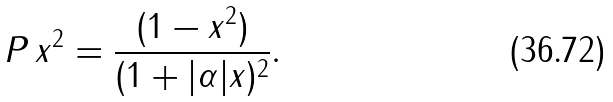Convert formula to latex. <formula><loc_0><loc_0><loc_500><loc_500>P \, x ^ { 2 } = \frac { ( 1 - x ^ { 2 } ) } { ( 1 + | \alpha | x ) ^ { 2 } } .</formula> 